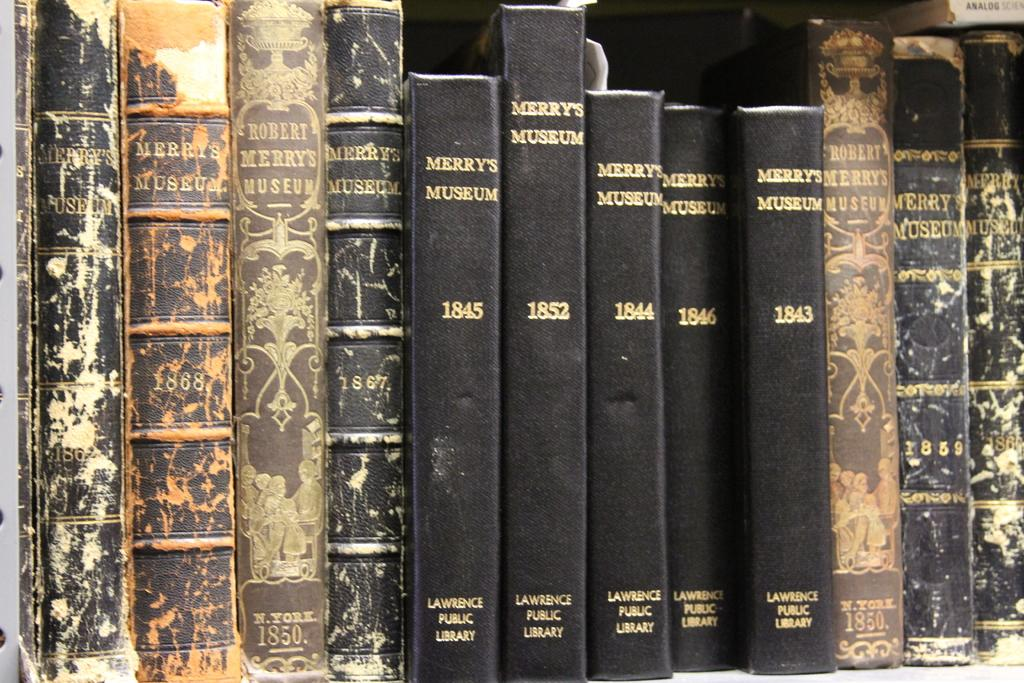<image>
Render a clear and concise summary of the photo. A collection of Merry's Museum books from Lawrence Public Library on a shelf. 